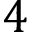Convert formula to latex. <formula><loc_0><loc_0><loc_500><loc_500>4</formula> 